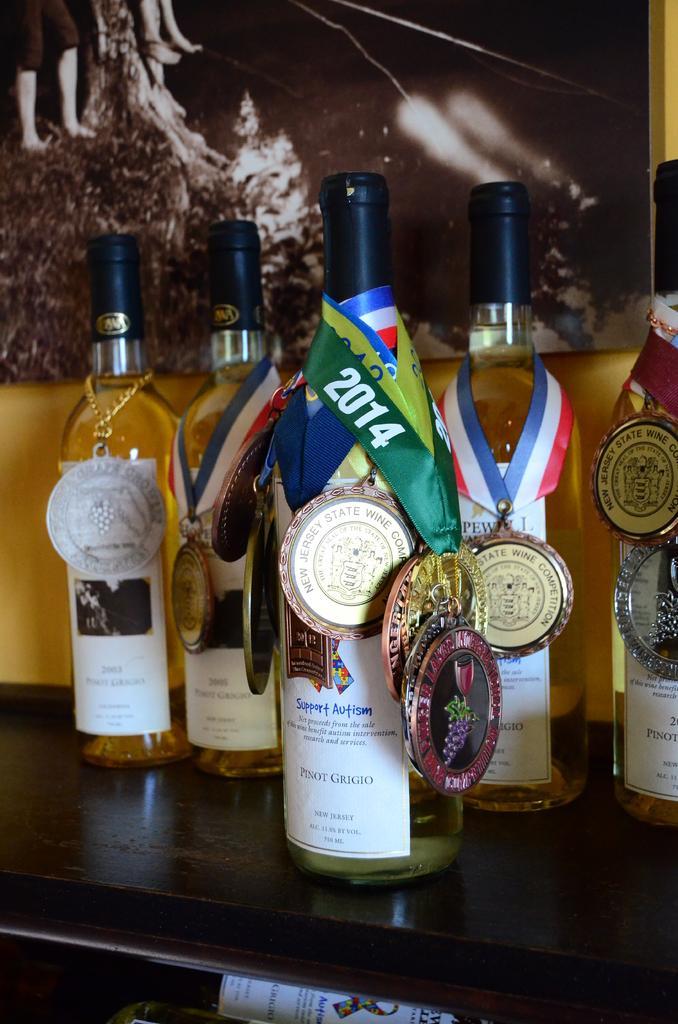Could you give a brief overview of what you see in this image? In this picture we can see different types of medals around the neck of the bottles. This is a table. on the background we can see one scenery. 